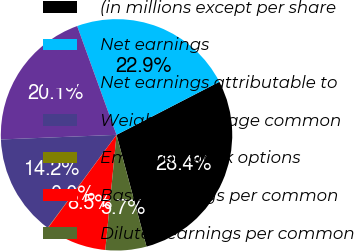Convert chart to OTSL. <chart><loc_0><loc_0><loc_500><loc_500><pie_chart><fcel>(in millions except per share<fcel>Net earnings<fcel>Net earnings attributable to<fcel>Weighted-average common<fcel>Employee stock options<fcel>Basic earnings per common<fcel>Diluted earnings per common<nl><fcel>28.41%<fcel>22.95%<fcel>20.11%<fcel>14.23%<fcel>0.04%<fcel>8.55%<fcel>5.72%<nl></chart> 